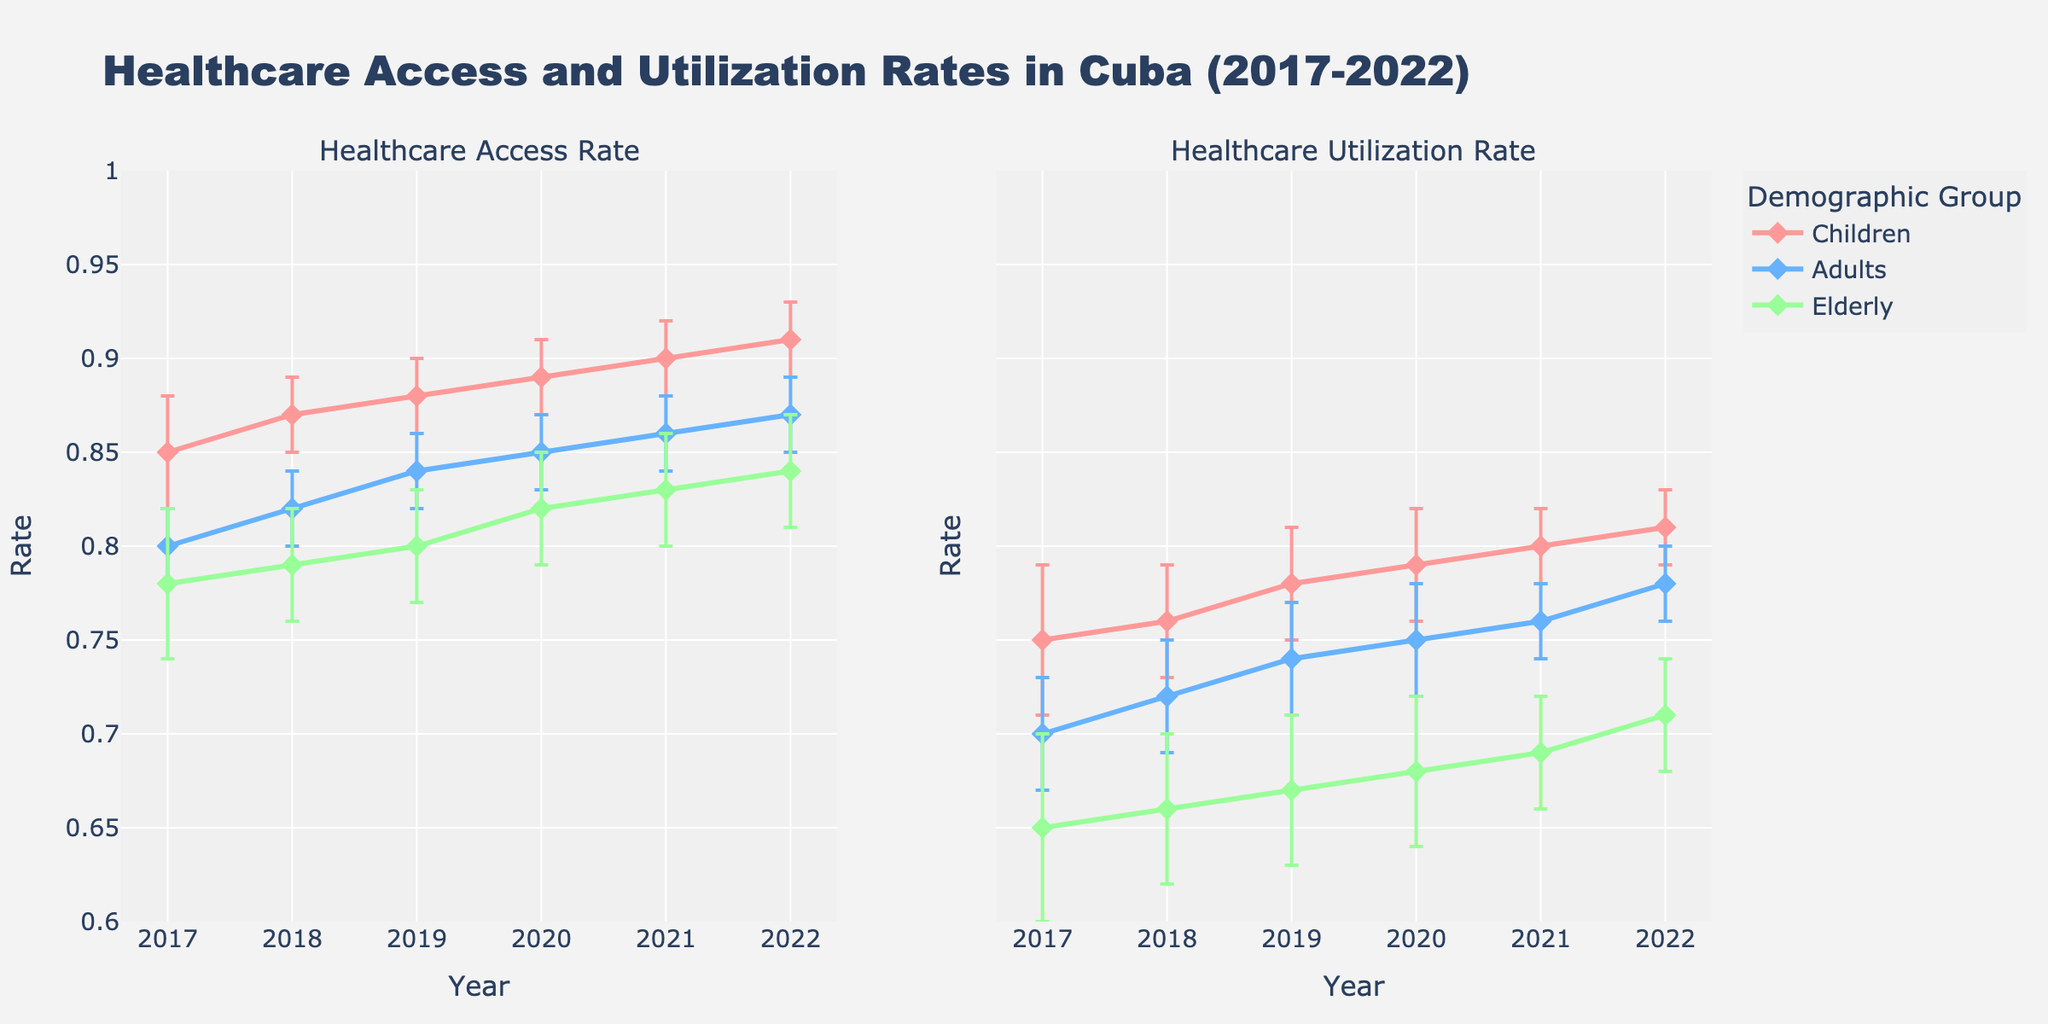Which demographic group had the highest healthcare access rate in 2022? Observe the figure and locate the data points for 2022. Compare the access rates for Children, Adults, and Elderly.
Answer: Children What was the healthcare utilization rate for Adults in 2020? Refer to the line plot for the "Healthcare Utilization Rate" subplot and find the data point for Adults in 2020.
Answer: 0.75 Which demographic group showed the largest increase in healthcare access rate from 2017 to 2022? Calculate the differences in healthcare access rates for each group between 2017 and 2022. Children: 0.91 - 0.85 = 0.06, Adults: 0.87 - 0.80 = 0.07, Elderly: 0.84 - 0.78 = 0.06. The group with the largest difference is Adults.
Answer: Adults What is the general trend for healthcare access rates for the Elderly from 2017 to 2022? Follow the line for the Elderly in the "Healthcare Access Rate" subplot. The trend is generally upward from 0.78 in 2017 to 0.84 in 2022.
Answer: Increasing Which demographic group has shown the most consistent improvement in healthcare utilization rate over the years? Examine the trends for all groups in the "Healthcare Utilization Rate" subplot. Look for the group with steady increases with few fluctuations.
Answer: Children What is the error margin for the healthcare access rate for Children in 2019? Look at the error bars for Children in 2019 in the "Healthcare Access Rate" subplot.
Answer: 0.02 By how much did the healthcare utilization rate increase for Children from 2018 to 2021? Calculate the difference in utilization rates for Children between these years: 0.80 (2021) - 0.76 (2018) = 0.04.
Answer: 0.04 Which demographic group had the lowest healthcare utilization rate in any given year? Identify the lowest point in the "Healthcare Utilization Rate" subplot for any group: Elderly in 2017 with 0.65.
Answer: Elderly in 2017 What is the average healthcare access rate for Adults across the years shown? Sum the access rates for Adults across all years and divide by the number of years: (0.80 + 0.82 + 0.84 + 0.85 + 0.86 + 0.87) / 6 = 0.84.
Answer: 0.84 Which year showed the steepest increase in healthcare access rate for Adults? Consider the slopes of the line segments for Adults in the "Healthcare Access Rate" subplot; the steepest increase is from 2017 to 2018.
Answer: 2017-2018 